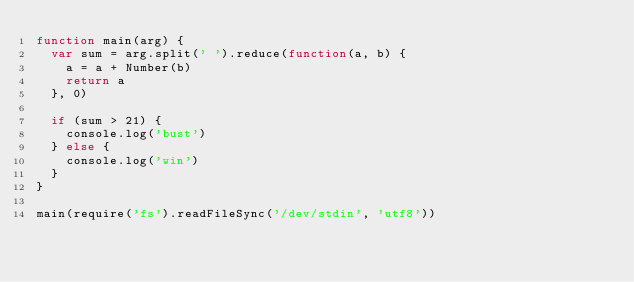<code> <loc_0><loc_0><loc_500><loc_500><_JavaScript_>function main(arg) {
  var sum = arg.split(' ').reduce(function(a, b) {
    a = a + Number(b)
    return a
  }, 0)

  if (sum > 21) {
    console.log('bust')
  } else {
    console.log('win')
  }
}

main(require('fs').readFileSync('/dev/stdin', 'utf8'))</code> 